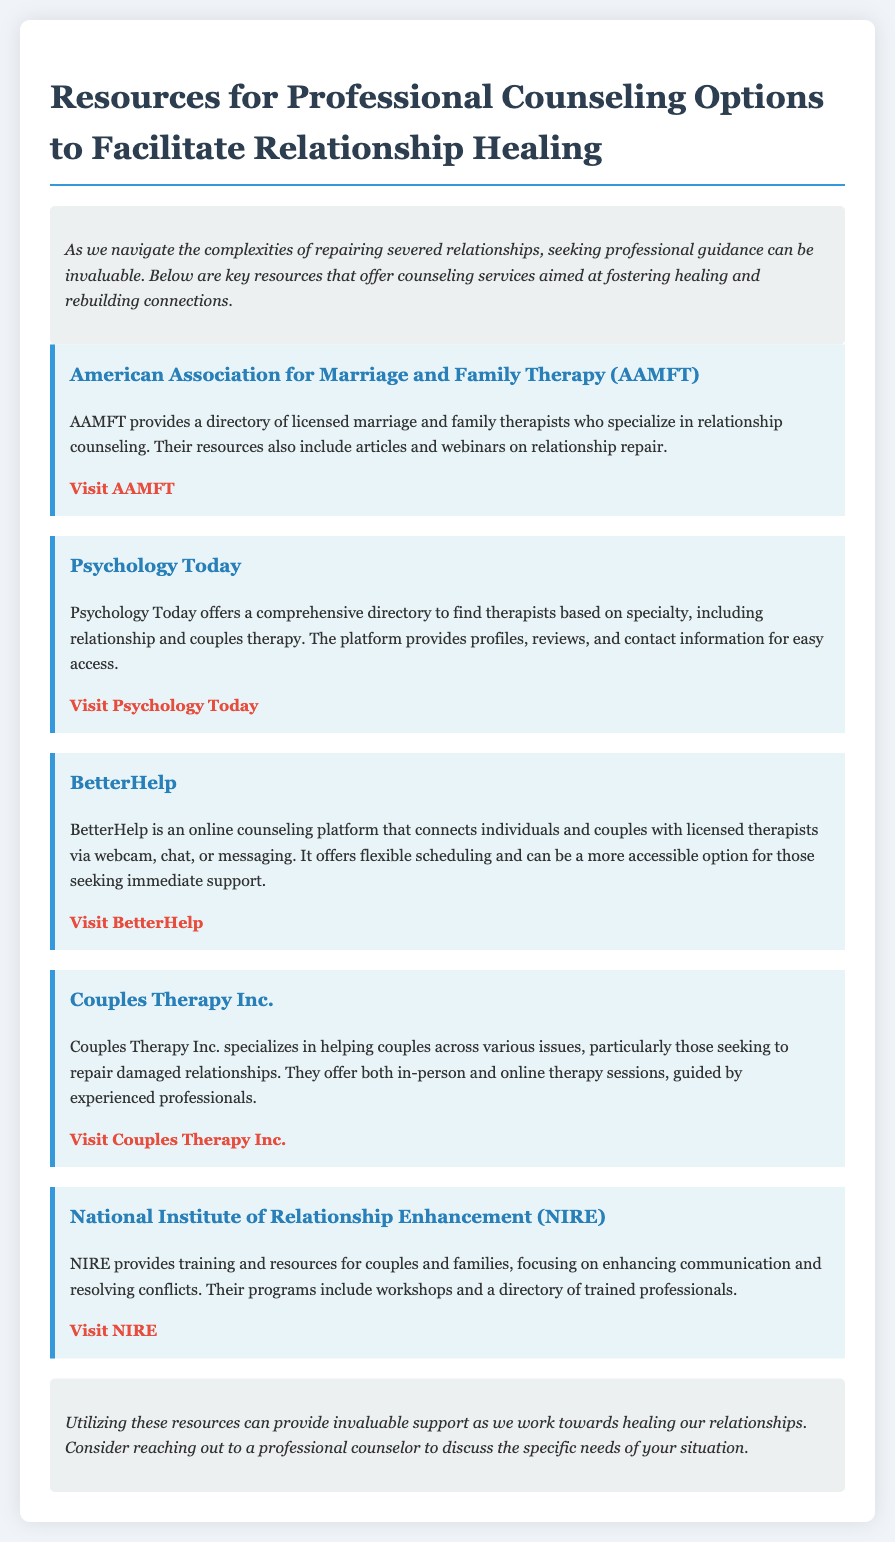What is the title of the document? The title is stated prominently at the top of the document.
Answer: Resources for Professional Counseling Options to Facilitate Relationship Healing What kind of therapy does AAMFT specialize in? The document specifies the type of therapy that AAMFT focuses on.
Answer: Relationship counseling How many resources are listed in the document? By counting the resources presented in the document, one can determine the total number.
Answer: Five What is the main service offered by BetterHelp? The document describes the main offering of BetterHelp clearly.
Answer: Online counseling Which organization provides training and resources for enhancing communication? The document names the organization that focuses on improving communication among couples and families.
Answer: National Institute of Relationship Enhancement (NIRE) What type of sessions does Couples Therapy Inc. offer? The document mentions the type of therapy sessions available at Couples Therapy Inc.
Answer: In-person and online therapy sessions What is the website for Psychology Today? The document provides the direct link to the Psychology Today platform for accessing their services.
Answer: https://www.psychologytoday.com/us/therapists What should one consider reaching out to when healing relationships? The document emphasizes a specific type of professional to connect with for relationship issues.
Answer: A professional counselor 